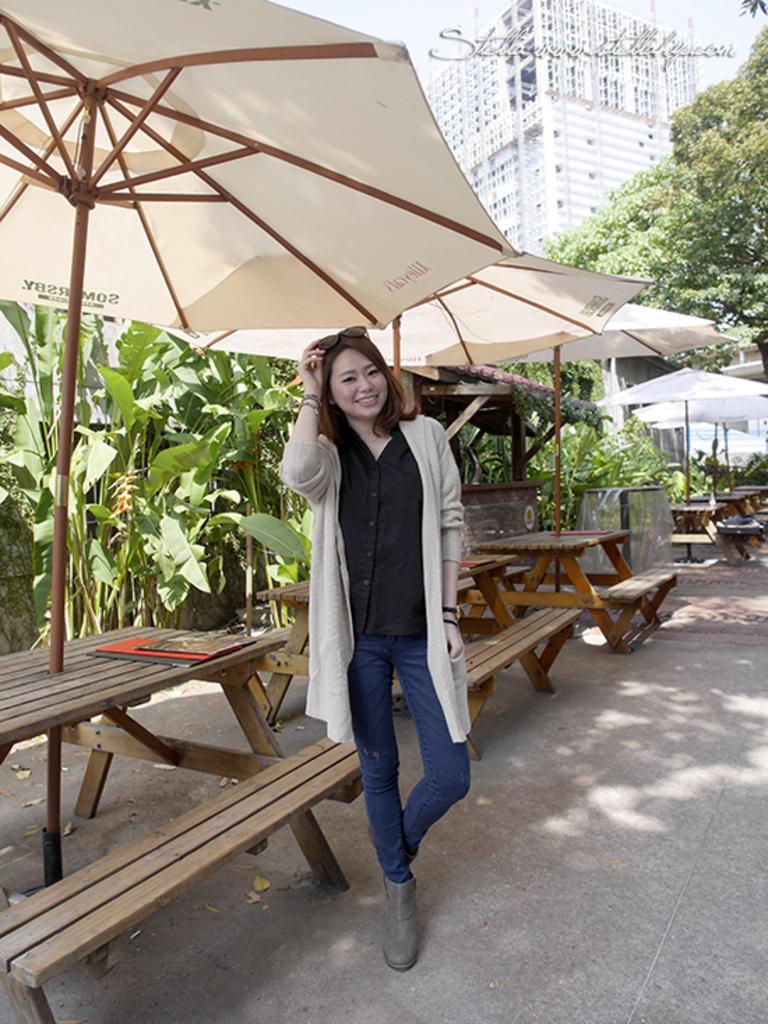Could you give a brief overview of what you see in this image? This picture is of outside. In the center there is a woman wearing black color shirt, smiling and standing. On the left there are tables and benches and umbrellas are attached to the tables. In the background we can see the buildings, trees and the sky. 